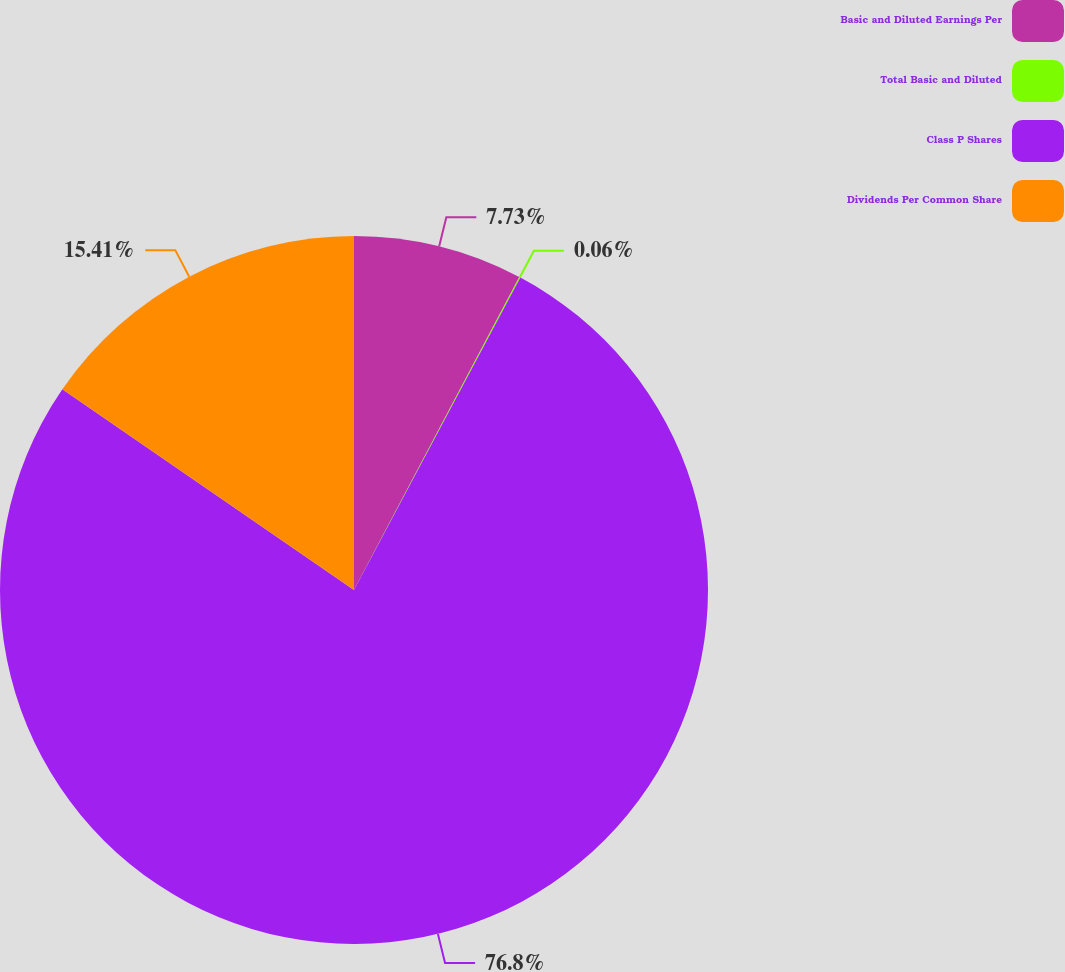Convert chart. <chart><loc_0><loc_0><loc_500><loc_500><pie_chart><fcel>Basic and Diluted Earnings Per<fcel>Total Basic and Diluted<fcel>Class P Shares<fcel>Dividends Per Common Share<nl><fcel>7.73%<fcel>0.06%<fcel>76.8%<fcel>15.41%<nl></chart> 